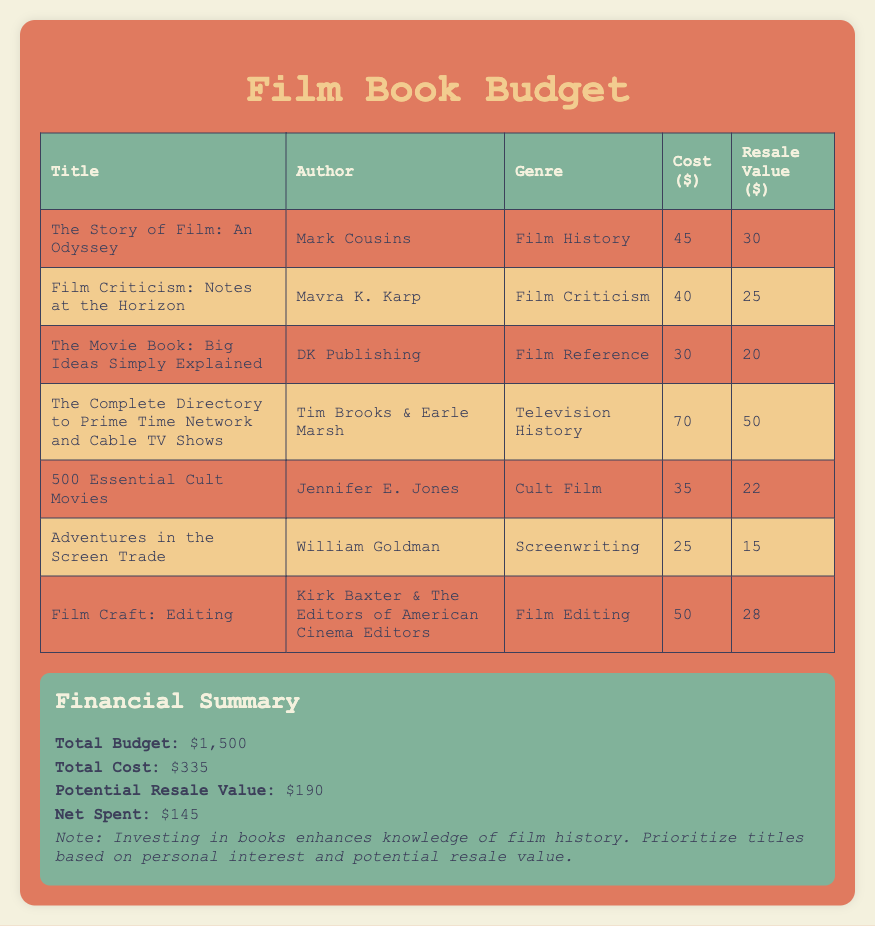What is the total budget? The total budget is stated in the summary section of the document.
Answer: $1,500 Who is the author of "The Story of Film: An Odyssey"? The author's name can be found in the corresponding row of the table under the "Author" column.
Answer: Mark Cousins What is the genre of "500 Essential Cult Movies"? The genre is listed in the corresponding row of the table under the "Genre" column.
Answer: Cult Film What is the cost of "Film Criticism: Notes at the Horizon"? The cost is provided in the table within the "Cost" column for that specific title.
Answer: $40 What is the potential resale value of "The Movie Book: Big Ideas Simply Explained"? The resale value is listed in the table under the "Resale Value" column for that title.
Answer: $20 Which book has the highest cost? The book with the highest cost can be determined by examining the "Cost" column in the table.
Answer: $70 What is the net spent on the book purchases? The net spent is calculated from the summary section of the document.
Answer: $145 Which author wrote about screenwriting? This author can be found by checking the table under the relevant "Author" column associated with the "Screenwriting" genre.
Answer: William Goldman What is the total cost of all the books listed? The total cost is found in the summary section under "Total Cost".
Answer: $335 What is the potential resale value of the entire collection? The potential resale value is provided in the financial summary section.
Answer: $190 